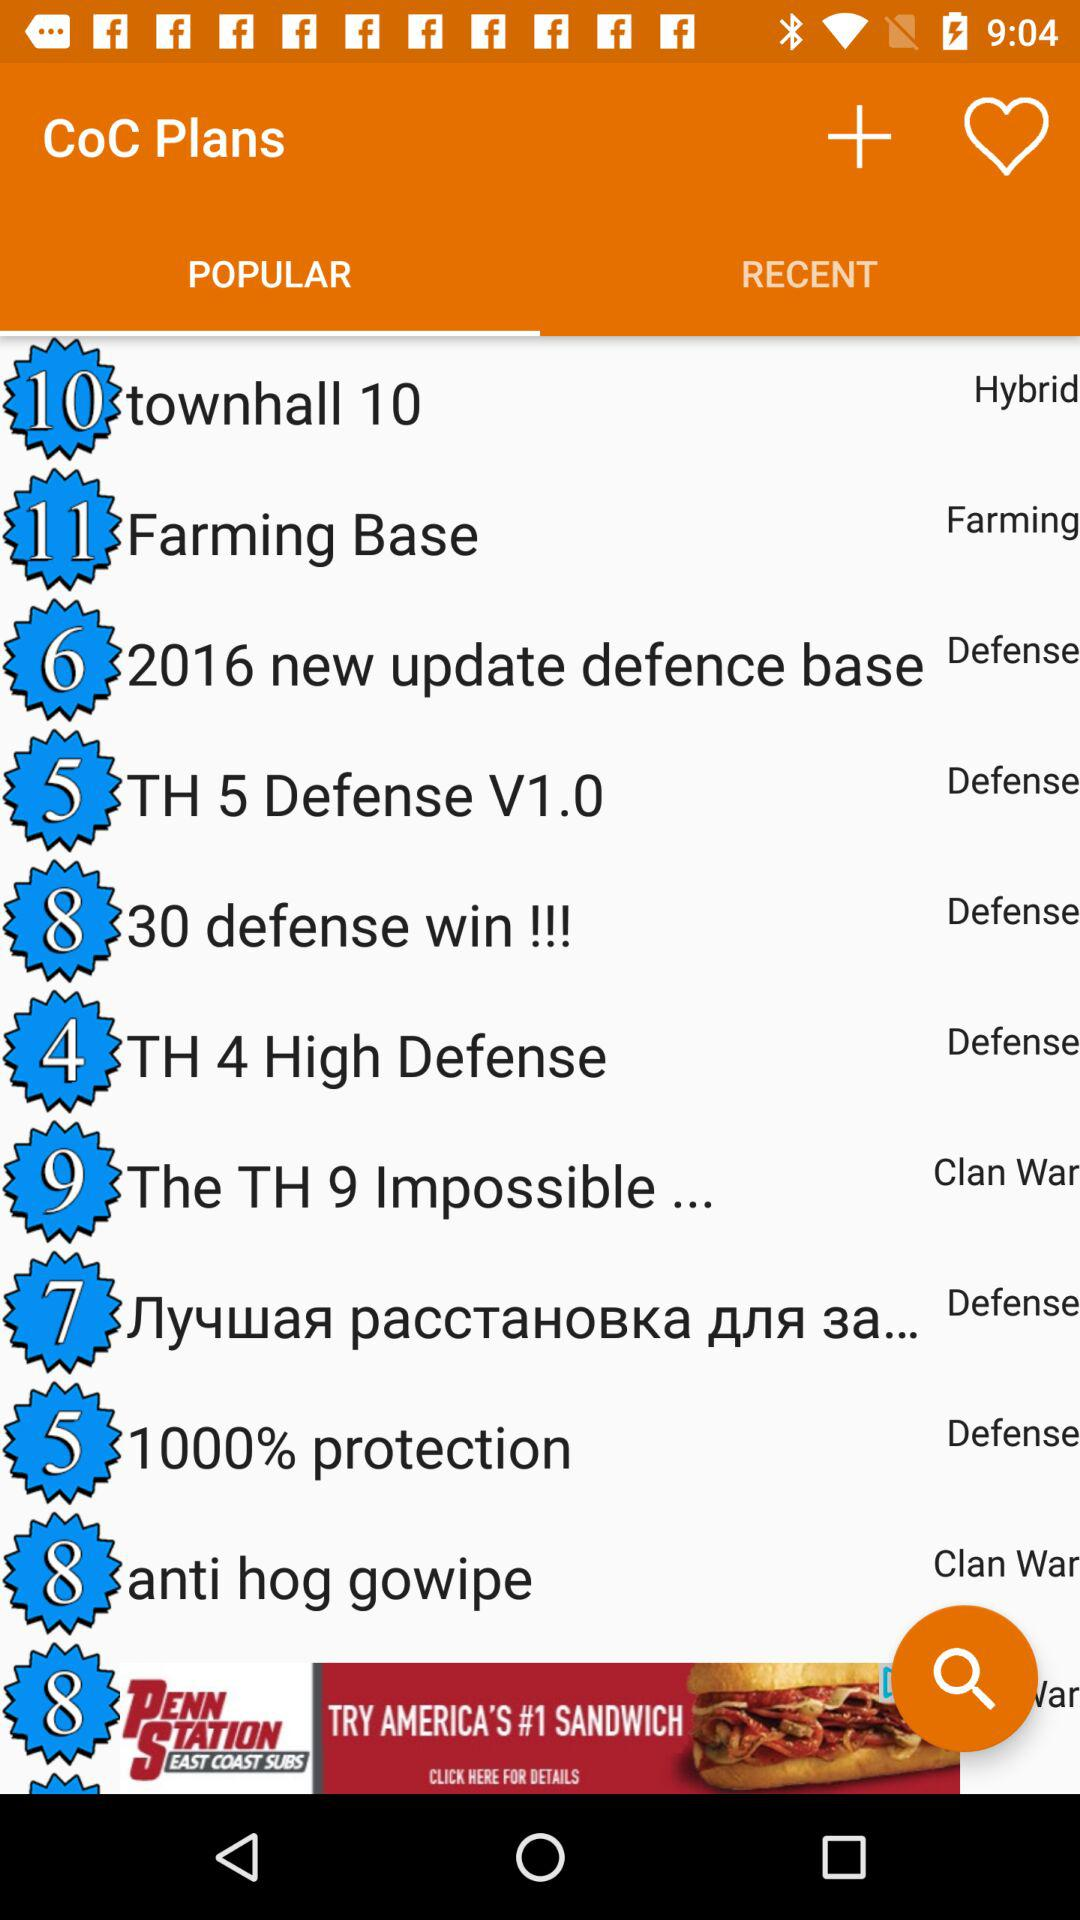Which type of plan is the "Farming Base"? "Farming Base" is a "Farming" type plan. 